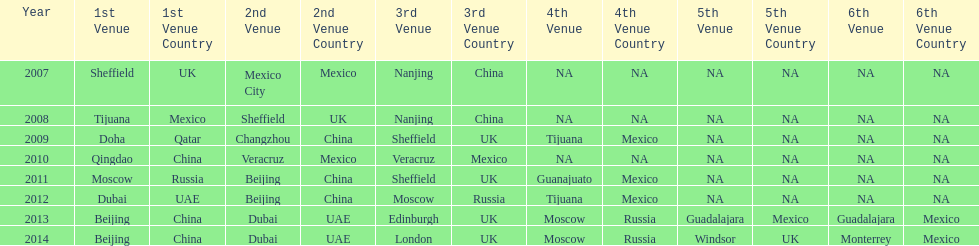Between 2007 and 2012, which year had a greater number of venues? 2012. 